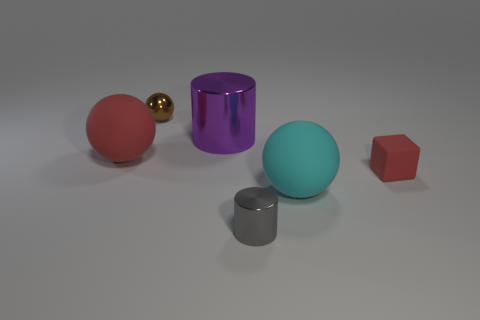What is the shape of the large thing that is the same color as the tiny cube?
Offer a terse response. Sphere. How many red rubber things have the same size as the purple cylinder?
Your answer should be very brief. 1. There is a cyan matte sphere on the left side of the small block; does it have the same size as the cylinder that is in front of the tiny red thing?
Your answer should be compact. No. How many objects are big purple spheres or red rubber balls in front of the large shiny thing?
Keep it short and to the point. 1. The big shiny cylinder has what color?
Ensure brevity in your answer.  Purple. There is a cylinder behind the cylinder in front of the large thing on the left side of the brown metallic thing; what is its material?
Give a very brief answer. Metal. What is the size of the ball that is the same material as the large cyan object?
Offer a very short reply. Large. Are there any large matte things that have the same color as the small cube?
Your answer should be compact. Yes. Does the gray shiny thing have the same size as the red rubber thing on the right side of the small gray cylinder?
Offer a terse response. Yes. There is a metallic object in front of the rubber sphere behind the cube; how many big purple cylinders are behind it?
Ensure brevity in your answer.  1. 